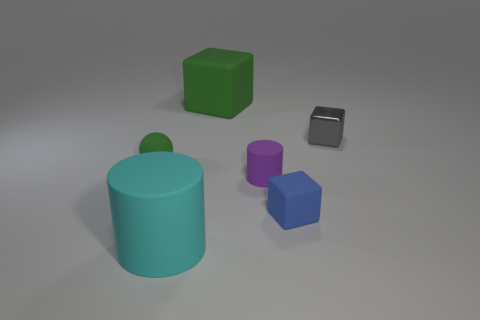Is there any other thing that has the same material as the gray block?
Your answer should be compact. No. How many things are either purple matte cylinders or big green cylinders?
Your response must be concise. 1. What is the size of the matte cylinder behind the blue rubber block?
Offer a terse response. Small. Is there anything else that has the same size as the metal object?
Ensure brevity in your answer.  Yes. What color is the object that is both in front of the purple thing and to the left of the small cylinder?
Keep it short and to the point. Cyan. Are the tiny cube that is behind the blue rubber thing and the green ball made of the same material?
Your answer should be compact. No. There is a small sphere; is it the same color as the large object that is behind the gray metal cube?
Offer a terse response. Yes. There is a small green rubber ball; are there any tiny balls to the right of it?
Offer a terse response. No. Do the green rubber object to the left of the large green matte thing and the matte cylinder in front of the purple cylinder have the same size?
Provide a succinct answer. No. Are there any other purple metallic things of the same size as the purple thing?
Give a very brief answer. No. 